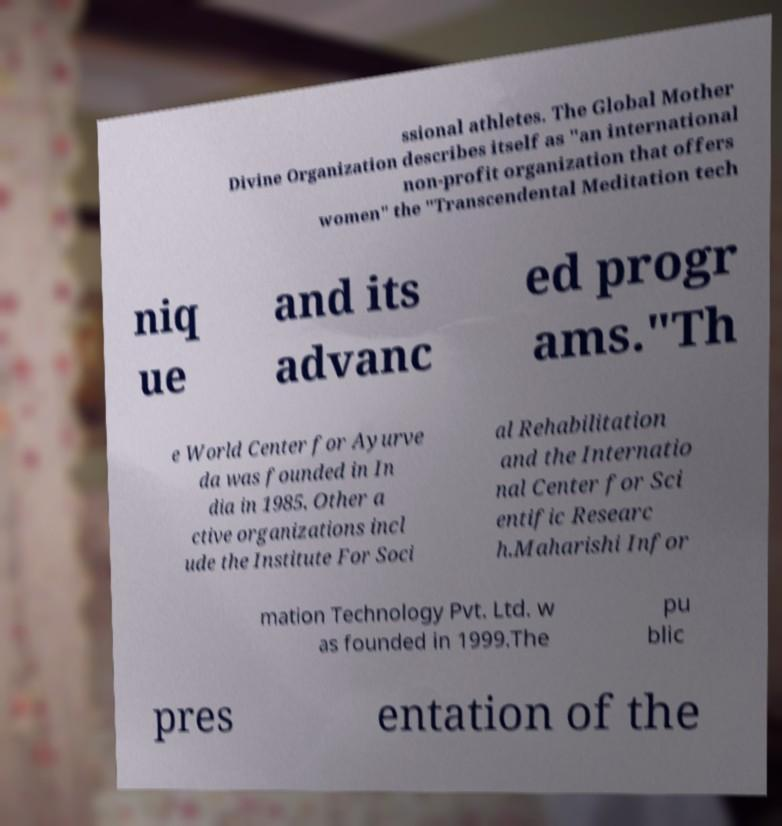What messages or text are displayed in this image? I need them in a readable, typed format. ssional athletes. The Global Mother Divine Organization describes itself as "an international non-profit organization that offers women" the "Transcendental Meditation tech niq ue and its advanc ed progr ams."Th e World Center for Ayurve da was founded in In dia in 1985. Other a ctive organizations incl ude the Institute For Soci al Rehabilitation and the Internatio nal Center for Sci entific Researc h.Maharishi Infor mation Technology Pvt. Ltd. w as founded in 1999.The pu blic pres entation of the 